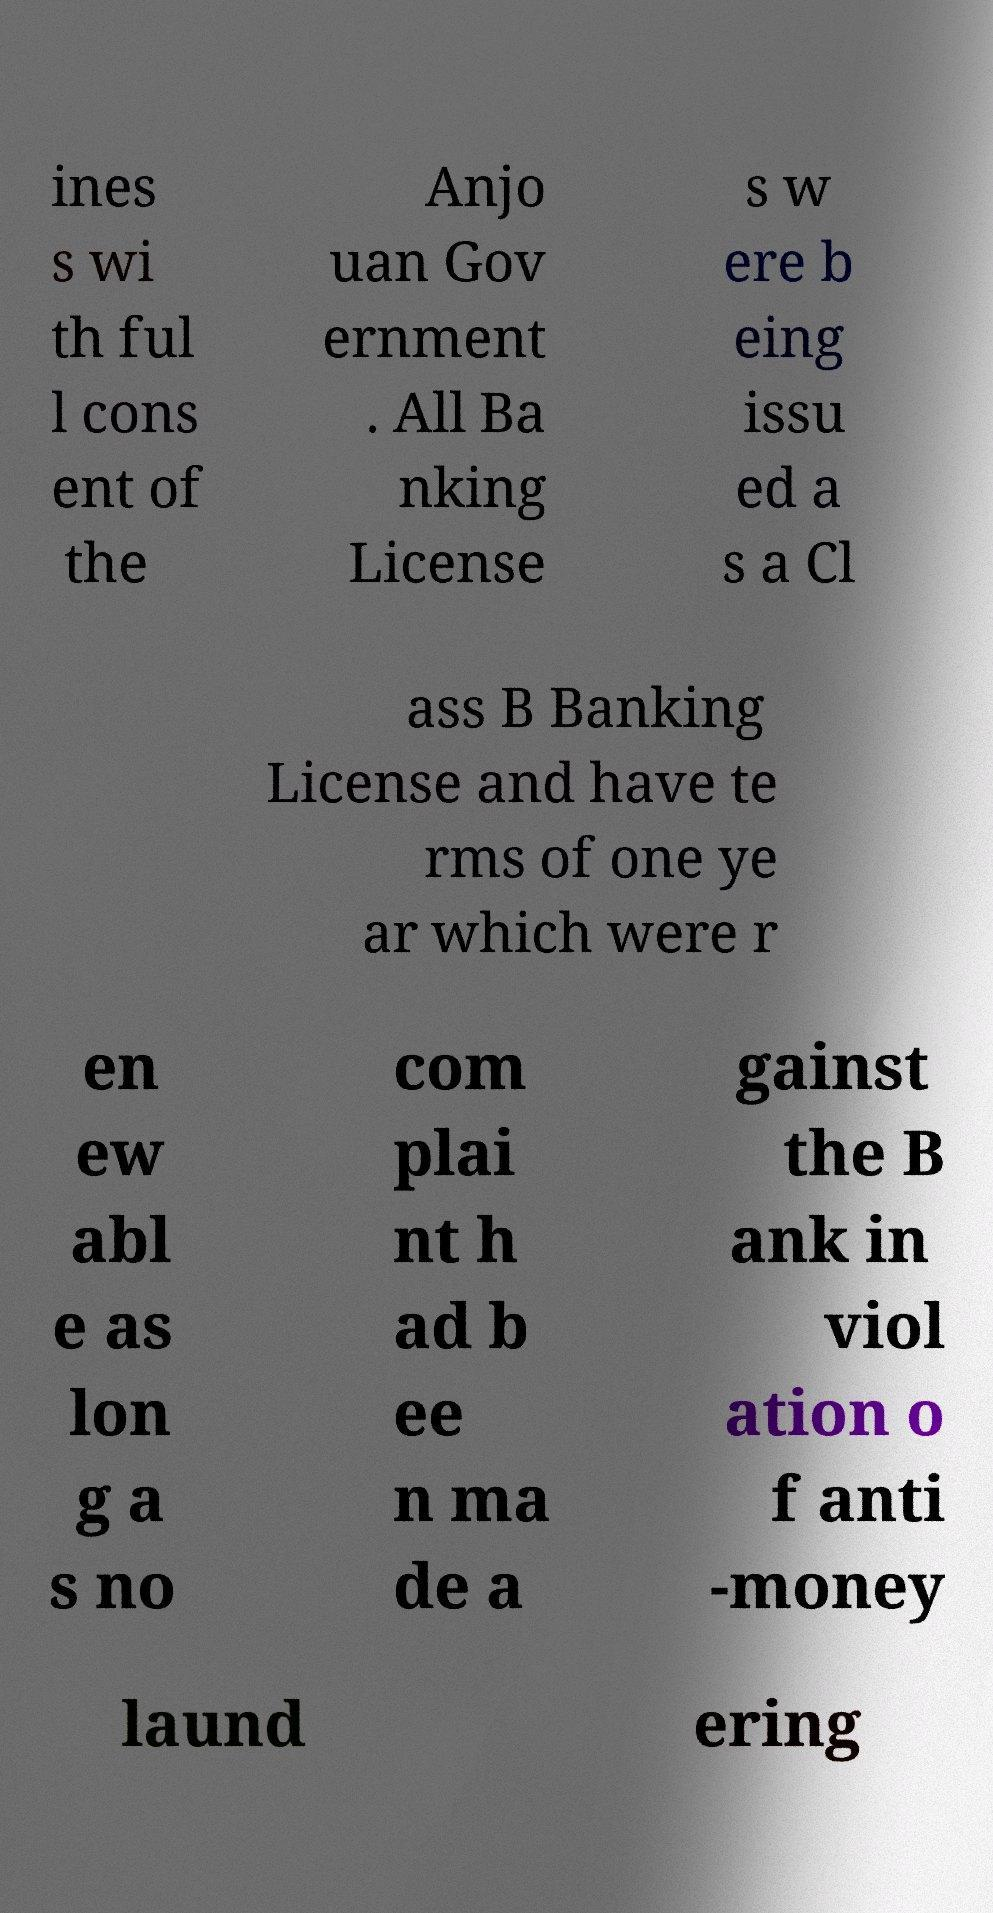Could you extract and type out the text from this image? ines s wi th ful l cons ent of the Anjo uan Gov ernment . All Ba nking License s w ere b eing issu ed a s a Cl ass B Banking License and have te rms of one ye ar which were r en ew abl e as lon g a s no com plai nt h ad b ee n ma de a gainst the B ank in viol ation o f anti -money laund ering 